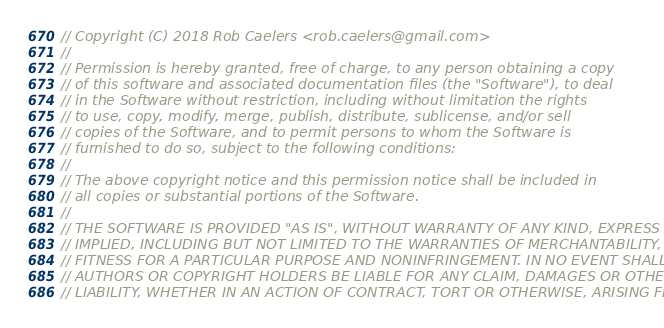Convert code to text. <code><loc_0><loc_0><loc_500><loc_500><_C++_>// Copyright (C) 2018 Rob Caelers <rob.caelers@gmail.com>
//
// Permission is hereby granted, free of charge, to any person obtaining a copy
// of this software and associated documentation files (the "Software"), to deal
// in the Software without restriction, including without limitation the rights
// to use, copy, modify, merge, publish, distribute, sublicense, and/or sell
// copies of the Software, and to permit persons to whom the Software is
// furnished to do so, subject to the following conditions:
//
// The above copyright notice and this permission notice shall be included in
// all copies or substantial portions of the Software.
//
// THE SOFTWARE IS PROVIDED "AS IS", WITHOUT WARRANTY OF ANY KIND, EXPRESS OR
// IMPLIED, INCLUDING BUT NOT LIMITED TO THE WARRANTIES OF MERCHANTABILITY,
// FITNESS FOR A PARTICULAR PURPOSE AND NONINFRINGEMENT. IN NO EVENT SHALL THE
// AUTHORS OR COPYRIGHT HOLDERS BE LIABLE FOR ANY CLAIM, DAMAGES OR OTHER
// LIABILITY, WHETHER IN AN ACTION OF CONTRACT, TORT OR OTHERWISE, ARISING FROM,</code> 